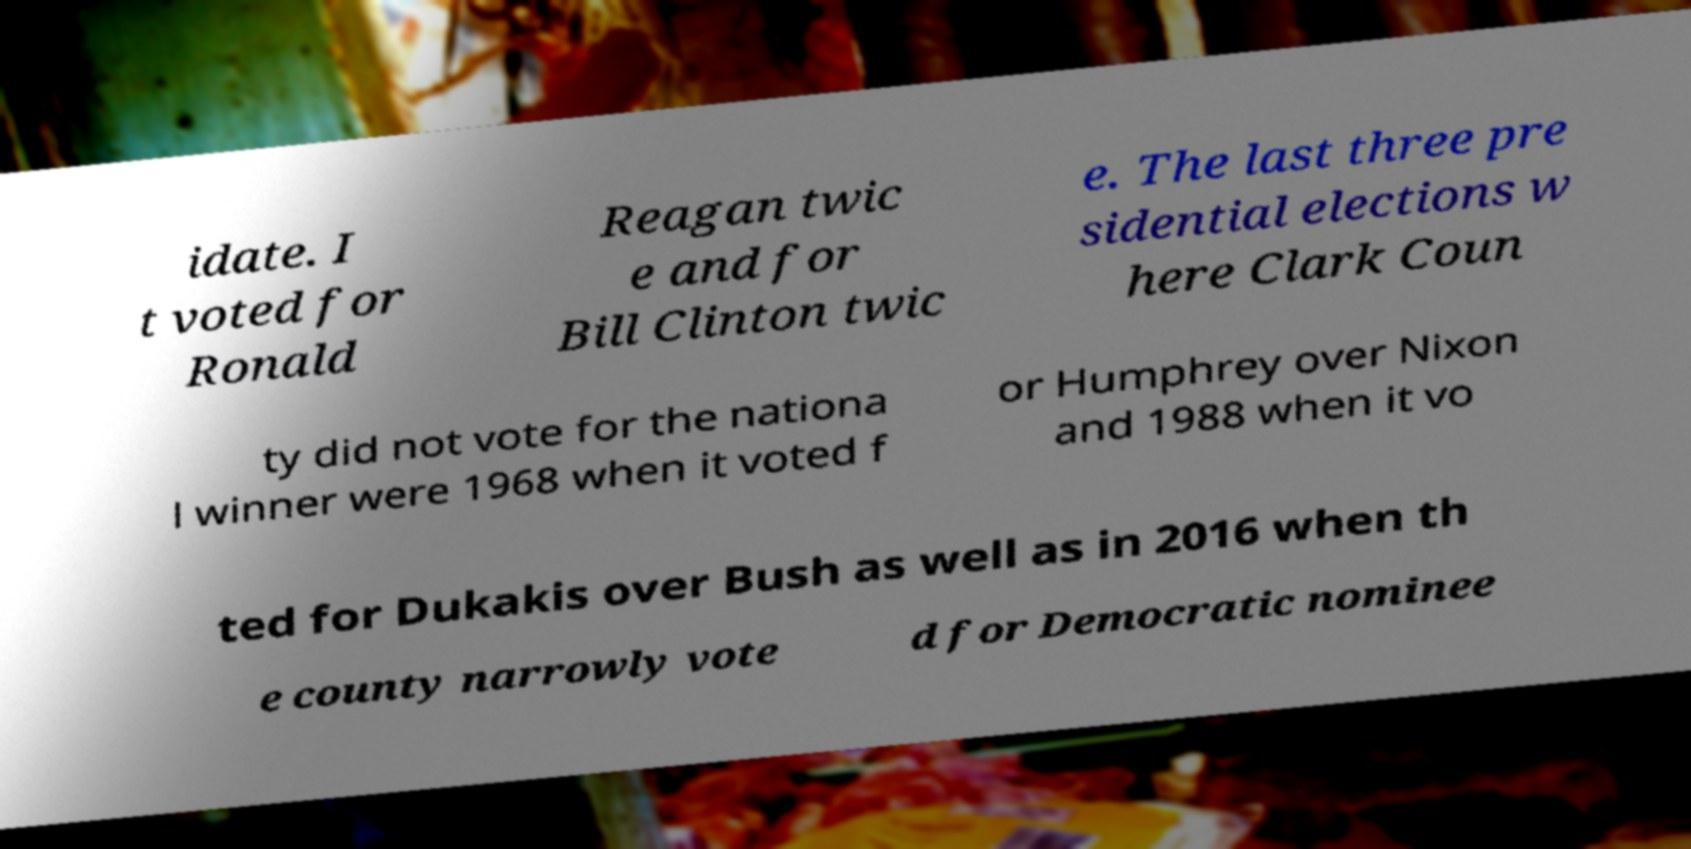I need the written content from this picture converted into text. Can you do that? idate. I t voted for Ronald Reagan twic e and for Bill Clinton twic e. The last three pre sidential elections w here Clark Coun ty did not vote for the nationa l winner were 1968 when it voted f or Humphrey over Nixon and 1988 when it vo ted for Dukakis over Bush as well as in 2016 when th e county narrowly vote d for Democratic nominee 